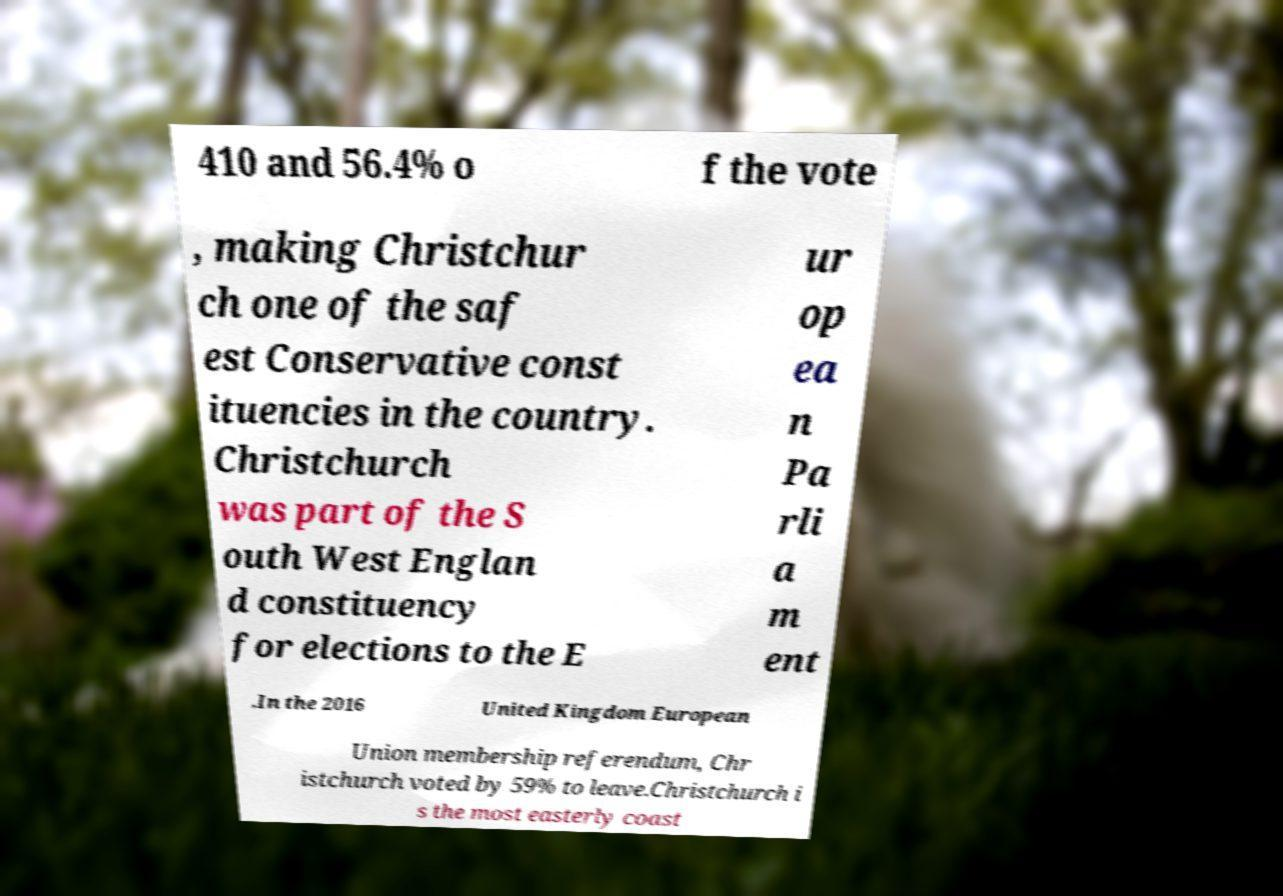Could you extract and type out the text from this image? 410 and 56.4% o f the vote , making Christchur ch one of the saf est Conservative const ituencies in the country. Christchurch was part of the S outh West Englan d constituency for elections to the E ur op ea n Pa rli a m ent .In the 2016 United Kingdom European Union membership referendum, Chr istchurch voted by 59% to leave.Christchurch i s the most easterly coast 